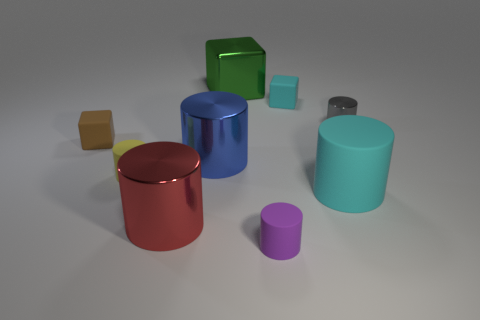Subtract all purple cylinders. How many cylinders are left? 5 Subtract all large matte cylinders. How many cylinders are left? 5 Subtract all brown cylinders. Subtract all cyan balls. How many cylinders are left? 6 Subtract all cylinders. How many objects are left? 3 Add 5 small yellow things. How many small yellow things exist? 6 Subtract 1 brown cubes. How many objects are left? 8 Subtract all tiny yellow rubber things. Subtract all rubber things. How many objects are left? 3 Add 1 green shiny things. How many green shiny things are left? 2 